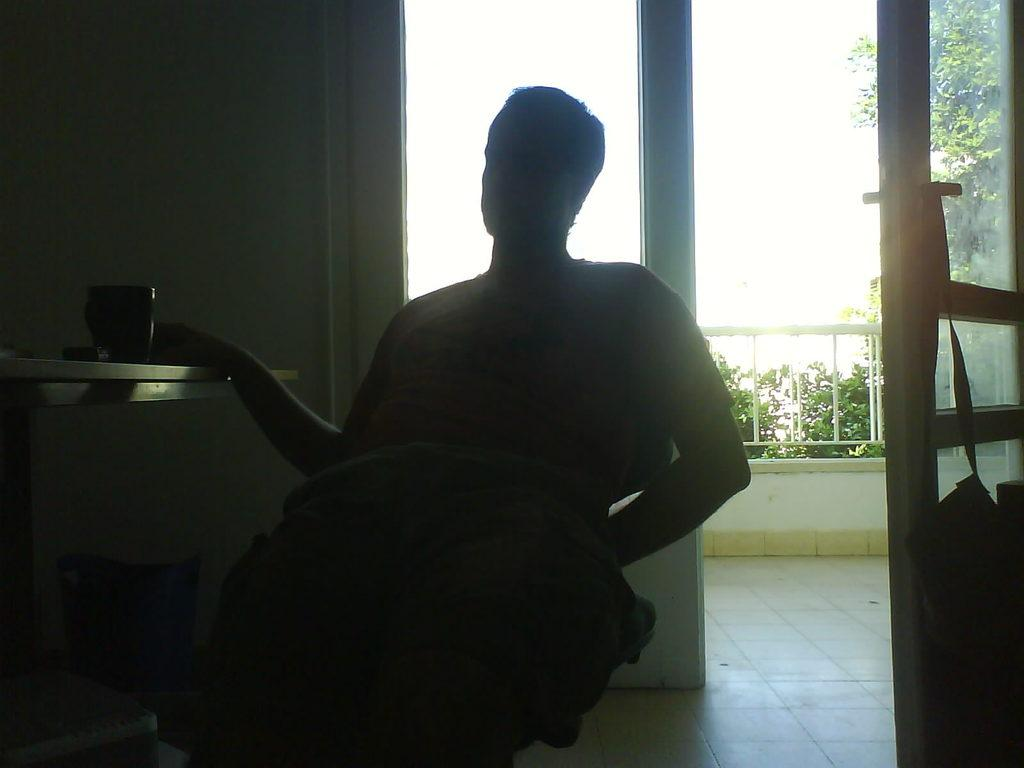What is the person in the image doing? There is a person sitting in the image. What is located near the person? There is a table near the person. What is on the table? There is a cup on the table. What can be seen in the background of the image? There are doors, a railing, and trees in the background of the image. What type of smell can be detected coming from the steam in the image? There is no steam present in the image, so it is not possible to detect any smell. 